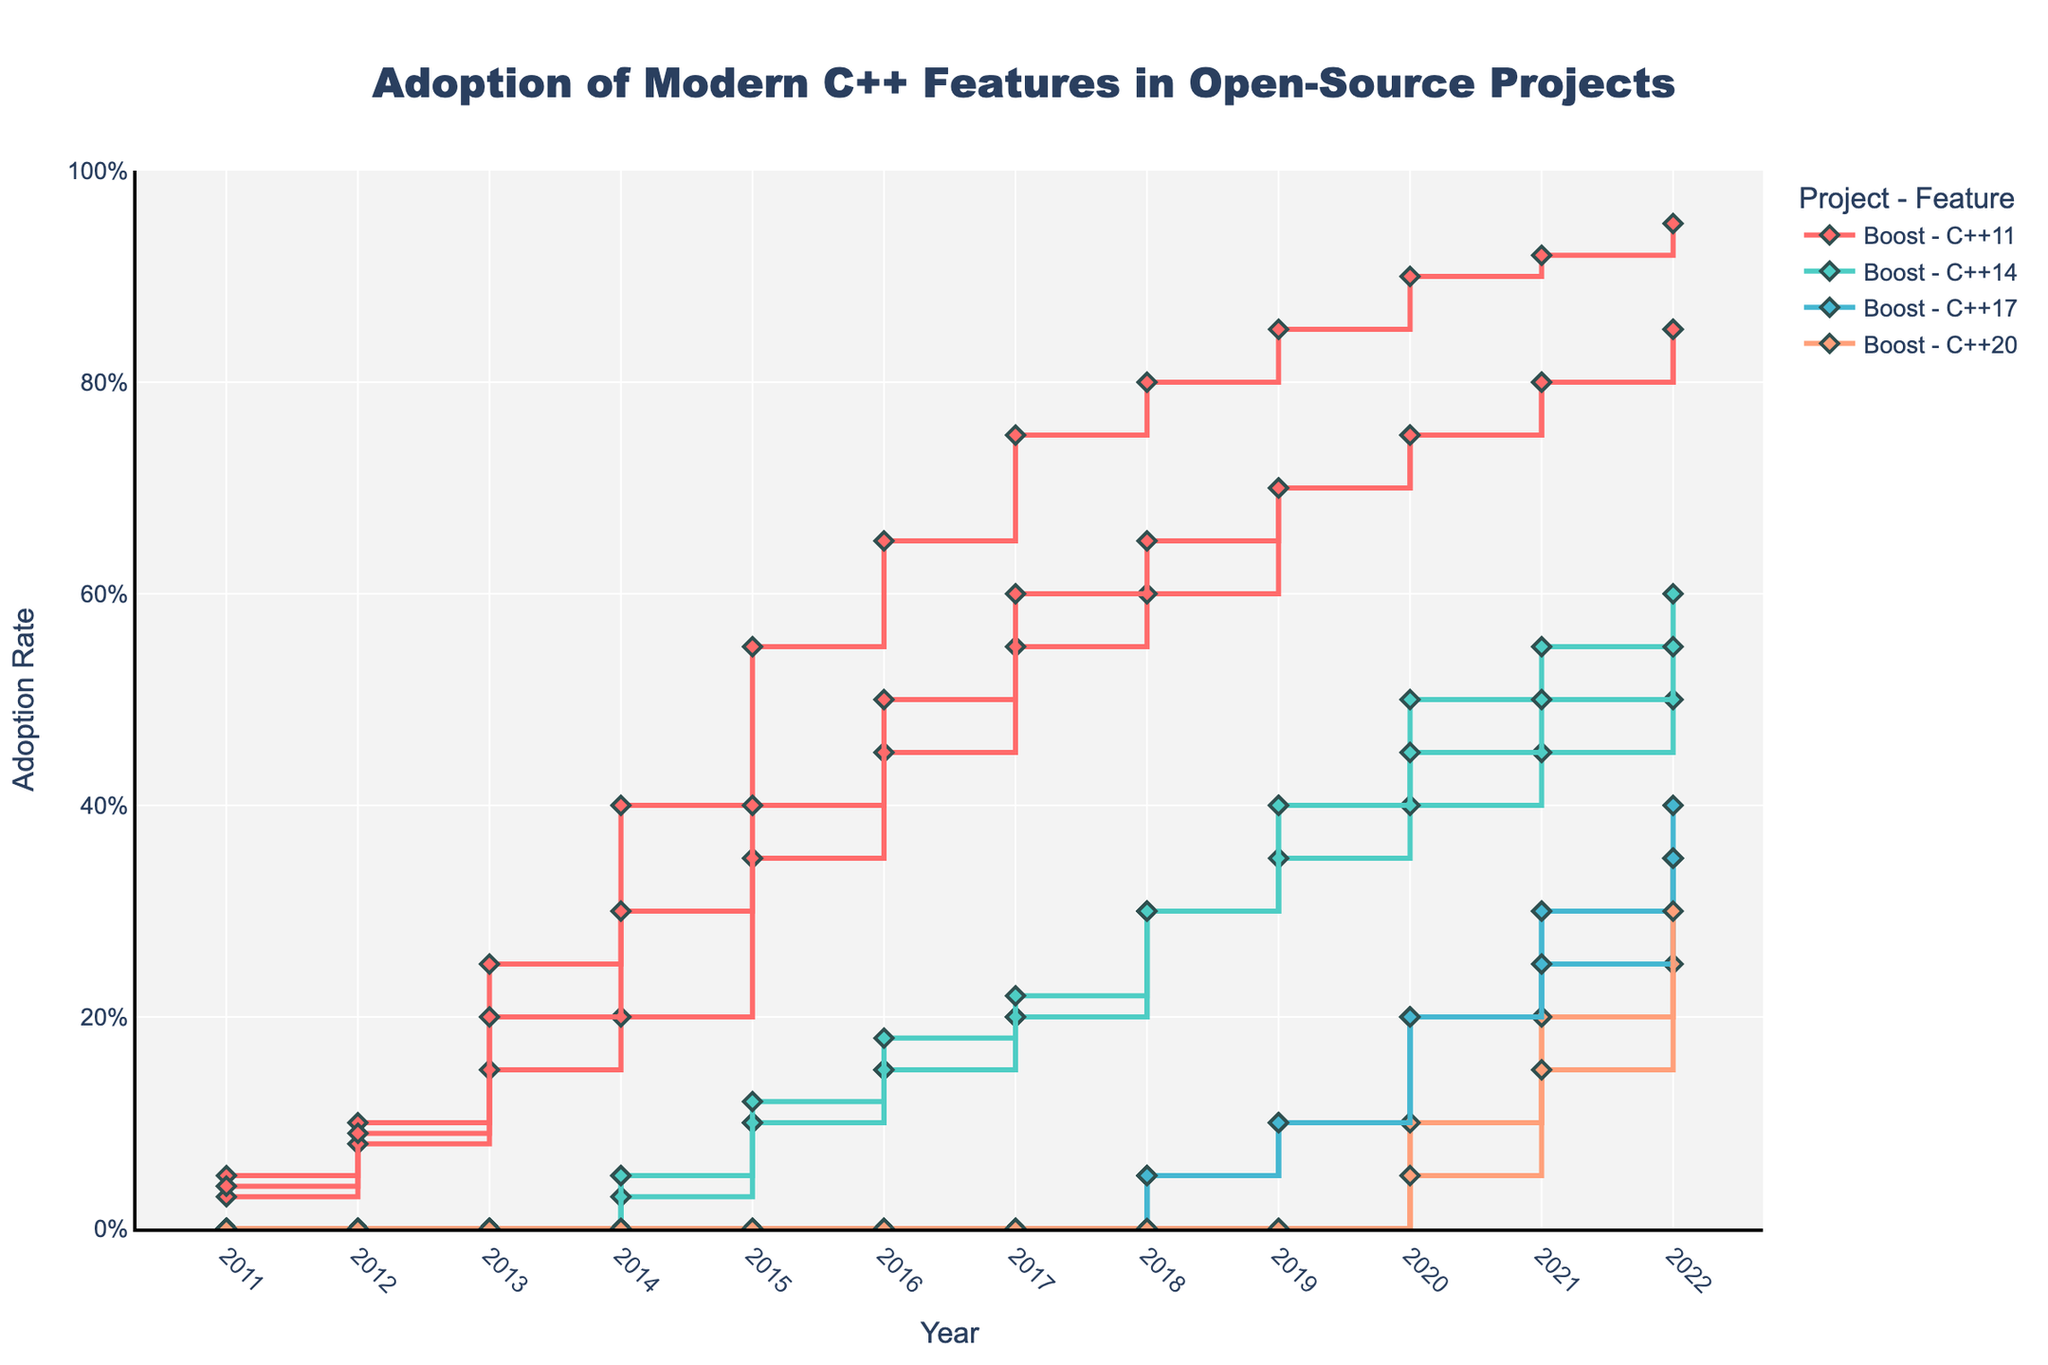What is the title of the figure? The title of the figure is located at the top and reads "Adoption of Modern C++ Features in Open-Source Projects".
Answer: Adoption of Modern C++ Features in Open-Source Projects What are the four C++ features being tracked in this plot? By looking at the legend and the lines in the plot, the four C++ features being tracked are C++11, C++14, C++17, and C++20.
Answer: C++11, C++14, C++17, C++20 Which C++ feature has the highest adoption rate in 2022 for Boost? To find this, look at the end of the Boost lines in 2022. The line with the highest value is for C++11.
Answer: C++11 In 2016, which project had the highest adoption rate for C++11? Locate the year 2016 on the x-axis and compare the heights of C++11 lines for each project. Boost has the highest rate in 2016.
Answer: Boost How does the adoption of C++20 in Qt compare from 2021 to 2022? Observe the C++20 line for Qt between 2021 and 2022. The adoption rate increases from 0.15 to 0.30.
Answer: Increase What is the difference in the adoption rate of C++17 between Boost and OpenCV in 2020? In 2020, locate the C++17 lines for both Boost (0.20) and OpenCV (0.20). Subtract OpenCV's rate from Boost's rate.
Answer: 0.0 Which project was faster in adopting C++14 between Boost and Qt? Look at the C++14 lines for both projects. Qt started adoption in 2014 while Boost also started in 2014, but Qt's adoption rate increases faster.
Answer: Qt How did the adoption of C++11 in OpenCV progress from 2011 to 2014? Follow the C++11 line for OpenCV from 2011 to 2014. The rate increases from 0.03 to 0.20.
Answer: Increase What is the rate of adoption of C++14 in OpenCV in 2020 compared to 2022? Locate the C++14 line for OpenCV in 2020 (0.40) and in 2022 (0.50). The rate increases by 0.10.
Answer: Increase by 0.10 Which year did Boost's C++11 adoption rate reach or exceed 0.75? Find the C++11 line for Boost and look for the first year the rate is 0.75 or higher. It reaches 0.75 in 2017.
Answer: 2017 